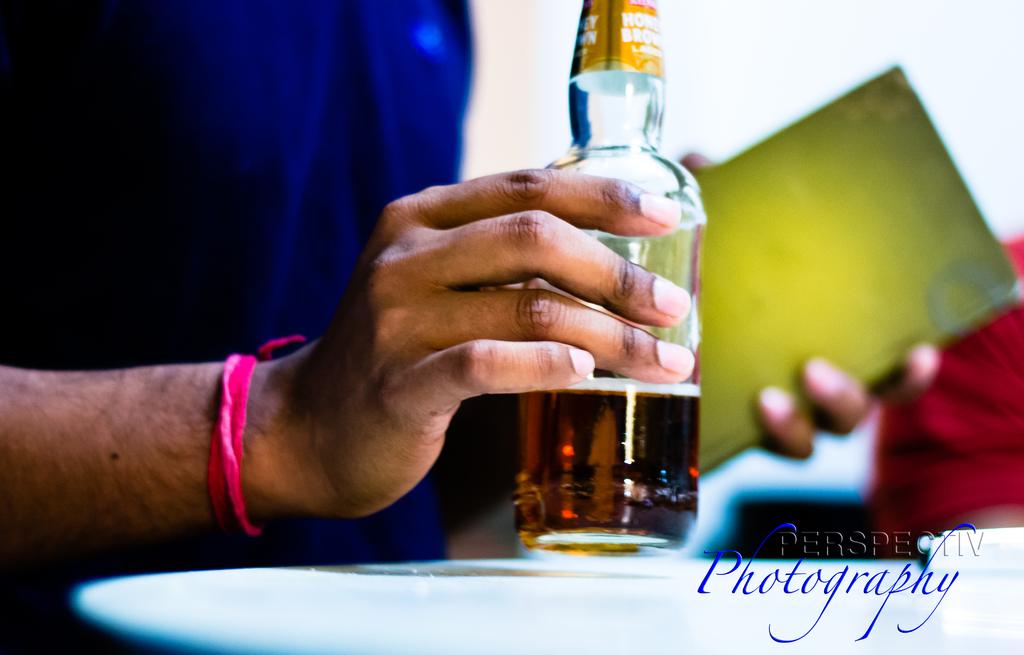What company took this photograph?
Offer a terse response. Perspectiv photography. 